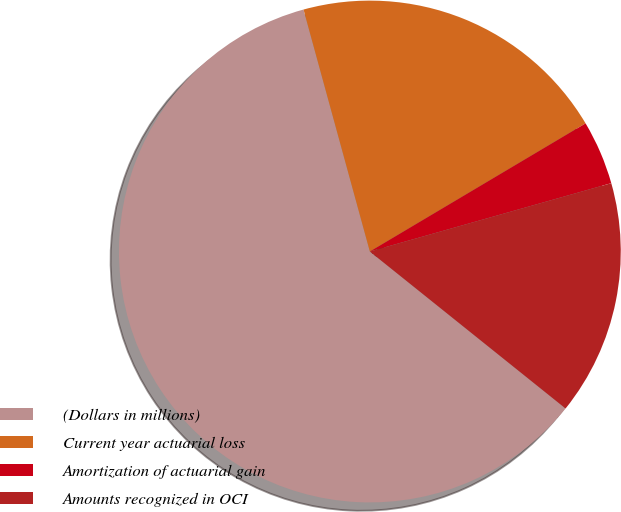<chart> <loc_0><loc_0><loc_500><loc_500><pie_chart><fcel>(Dollars in millions)<fcel>Current year actuarial loss<fcel>Amortization of actuarial gain<fcel>Amounts recognized in OCI<nl><fcel>59.99%<fcel>20.73%<fcel>4.14%<fcel>15.15%<nl></chart> 